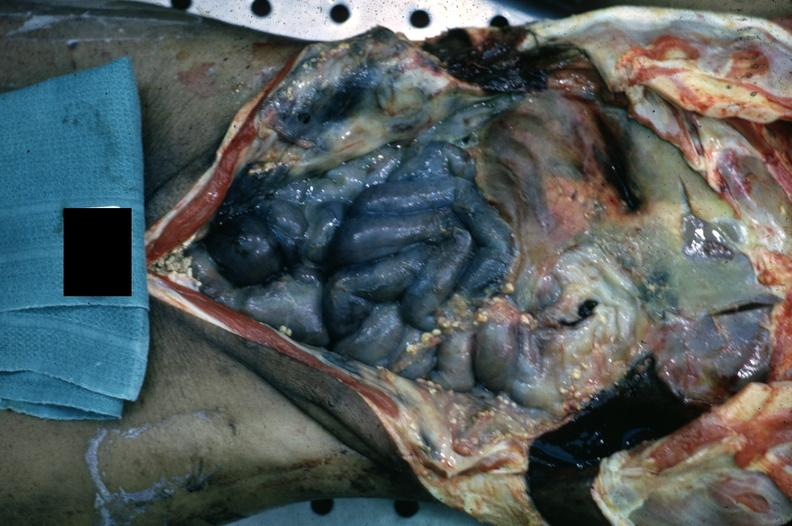s slices of liver and spleen typical tuberculous exudate is present on capsule of liver and spleen present?
Answer the question using a single word or phrase. No 